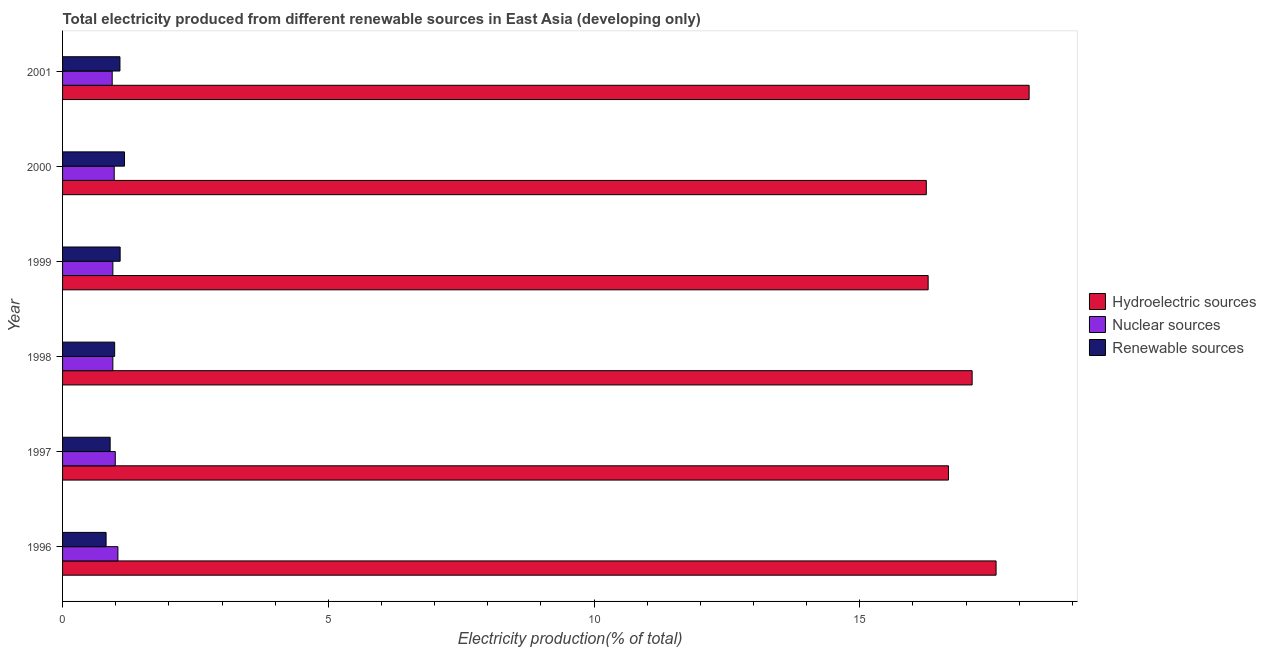How many different coloured bars are there?
Your response must be concise. 3. Are the number of bars per tick equal to the number of legend labels?
Keep it short and to the point. Yes. Are the number of bars on each tick of the Y-axis equal?
Your response must be concise. Yes. How many bars are there on the 2nd tick from the bottom?
Keep it short and to the point. 3. In how many cases, is the number of bars for a given year not equal to the number of legend labels?
Provide a short and direct response. 0. What is the percentage of electricity produced by hydroelectric sources in 1998?
Offer a very short reply. 17.11. Across all years, what is the maximum percentage of electricity produced by renewable sources?
Provide a short and direct response. 1.17. Across all years, what is the minimum percentage of electricity produced by nuclear sources?
Make the answer very short. 0.93. In which year was the percentage of electricity produced by renewable sources minimum?
Your answer should be very brief. 1996. What is the total percentage of electricity produced by nuclear sources in the graph?
Offer a very short reply. 5.83. What is the difference between the percentage of electricity produced by hydroelectric sources in 1998 and that in 1999?
Your response must be concise. 0.83. What is the difference between the percentage of electricity produced by hydroelectric sources in 1996 and the percentage of electricity produced by nuclear sources in 1999?
Your response must be concise. 16.62. In the year 1998, what is the difference between the percentage of electricity produced by nuclear sources and percentage of electricity produced by renewable sources?
Your response must be concise. -0.03. In how many years, is the percentage of electricity produced by nuclear sources greater than 11 %?
Provide a succinct answer. 0. What is the ratio of the percentage of electricity produced by hydroelectric sources in 1999 to that in 2000?
Your answer should be compact. 1. Is the percentage of electricity produced by hydroelectric sources in 1998 less than that in 1999?
Give a very brief answer. No. Is the difference between the percentage of electricity produced by nuclear sources in 1999 and 2001 greater than the difference between the percentage of electricity produced by renewable sources in 1999 and 2001?
Provide a short and direct response. Yes. What is the difference between the highest and the second highest percentage of electricity produced by nuclear sources?
Give a very brief answer. 0.05. What is the difference between the highest and the lowest percentage of electricity produced by hydroelectric sources?
Make the answer very short. 1.93. Is the sum of the percentage of electricity produced by renewable sources in 1996 and 1999 greater than the maximum percentage of electricity produced by nuclear sources across all years?
Offer a very short reply. Yes. What does the 2nd bar from the top in 1997 represents?
Provide a short and direct response. Nuclear sources. What does the 2nd bar from the bottom in 1999 represents?
Your answer should be very brief. Nuclear sources. Is it the case that in every year, the sum of the percentage of electricity produced by hydroelectric sources and percentage of electricity produced by nuclear sources is greater than the percentage of electricity produced by renewable sources?
Ensure brevity in your answer.  Yes. How many bars are there?
Make the answer very short. 18. Are all the bars in the graph horizontal?
Offer a very short reply. Yes. Are the values on the major ticks of X-axis written in scientific E-notation?
Your response must be concise. No. Does the graph contain any zero values?
Provide a short and direct response. No. Does the graph contain grids?
Offer a terse response. No. Where does the legend appear in the graph?
Your response must be concise. Center right. What is the title of the graph?
Provide a succinct answer. Total electricity produced from different renewable sources in East Asia (developing only). What is the Electricity production(% of total) of Hydroelectric sources in 1996?
Give a very brief answer. 17.56. What is the Electricity production(% of total) in Nuclear sources in 1996?
Provide a short and direct response. 1.04. What is the Electricity production(% of total) in Renewable sources in 1996?
Your answer should be compact. 0.82. What is the Electricity production(% of total) of Hydroelectric sources in 1997?
Your response must be concise. 16.67. What is the Electricity production(% of total) in Nuclear sources in 1997?
Offer a terse response. 0.99. What is the Electricity production(% of total) in Renewable sources in 1997?
Give a very brief answer. 0.9. What is the Electricity production(% of total) in Hydroelectric sources in 1998?
Make the answer very short. 17.11. What is the Electricity production(% of total) of Nuclear sources in 1998?
Provide a short and direct response. 0.95. What is the Electricity production(% of total) of Renewable sources in 1998?
Make the answer very short. 0.98. What is the Electricity production(% of total) in Hydroelectric sources in 1999?
Provide a short and direct response. 16.29. What is the Electricity production(% of total) of Nuclear sources in 1999?
Your response must be concise. 0.95. What is the Electricity production(% of total) of Renewable sources in 1999?
Your answer should be very brief. 1.08. What is the Electricity production(% of total) in Hydroelectric sources in 2000?
Provide a short and direct response. 16.25. What is the Electricity production(% of total) in Nuclear sources in 2000?
Provide a succinct answer. 0.97. What is the Electricity production(% of total) of Renewable sources in 2000?
Offer a very short reply. 1.17. What is the Electricity production(% of total) of Hydroelectric sources in 2001?
Provide a short and direct response. 18.19. What is the Electricity production(% of total) in Nuclear sources in 2001?
Give a very brief answer. 0.93. What is the Electricity production(% of total) in Renewable sources in 2001?
Make the answer very short. 1.08. Across all years, what is the maximum Electricity production(% of total) in Hydroelectric sources?
Make the answer very short. 18.19. Across all years, what is the maximum Electricity production(% of total) in Nuclear sources?
Keep it short and to the point. 1.04. Across all years, what is the maximum Electricity production(% of total) of Renewable sources?
Provide a succinct answer. 1.17. Across all years, what is the minimum Electricity production(% of total) of Hydroelectric sources?
Your answer should be compact. 16.25. Across all years, what is the minimum Electricity production(% of total) of Nuclear sources?
Provide a succinct answer. 0.93. Across all years, what is the minimum Electricity production(% of total) in Renewable sources?
Provide a short and direct response. 0.82. What is the total Electricity production(% of total) of Hydroelectric sources in the graph?
Your answer should be very brief. 102.07. What is the total Electricity production(% of total) of Nuclear sources in the graph?
Your answer should be compact. 5.83. What is the total Electricity production(% of total) of Renewable sources in the graph?
Keep it short and to the point. 6.02. What is the difference between the Electricity production(% of total) of Hydroelectric sources in 1996 and that in 1997?
Offer a terse response. 0.9. What is the difference between the Electricity production(% of total) in Nuclear sources in 1996 and that in 1997?
Keep it short and to the point. 0.05. What is the difference between the Electricity production(% of total) of Renewable sources in 1996 and that in 1997?
Offer a very short reply. -0.08. What is the difference between the Electricity production(% of total) in Hydroelectric sources in 1996 and that in 1998?
Your answer should be very brief. 0.45. What is the difference between the Electricity production(% of total) of Nuclear sources in 1996 and that in 1998?
Offer a terse response. 0.1. What is the difference between the Electricity production(% of total) of Renewable sources in 1996 and that in 1998?
Ensure brevity in your answer.  -0.16. What is the difference between the Electricity production(% of total) in Hydroelectric sources in 1996 and that in 1999?
Give a very brief answer. 1.28. What is the difference between the Electricity production(% of total) of Nuclear sources in 1996 and that in 1999?
Offer a very short reply. 0.09. What is the difference between the Electricity production(% of total) of Renewable sources in 1996 and that in 1999?
Offer a terse response. -0.26. What is the difference between the Electricity production(% of total) in Hydroelectric sources in 1996 and that in 2000?
Provide a succinct answer. 1.31. What is the difference between the Electricity production(% of total) in Nuclear sources in 1996 and that in 2000?
Keep it short and to the point. 0.07. What is the difference between the Electricity production(% of total) of Renewable sources in 1996 and that in 2000?
Make the answer very short. -0.35. What is the difference between the Electricity production(% of total) in Hydroelectric sources in 1996 and that in 2001?
Your answer should be very brief. -0.62. What is the difference between the Electricity production(% of total) of Nuclear sources in 1996 and that in 2001?
Offer a very short reply. 0.11. What is the difference between the Electricity production(% of total) of Renewable sources in 1996 and that in 2001?
Ensure brevity in your answer.  -0.26. What is the difference between the Electricity production(% of total) of Hydroelectric sources in 1997 and that in 1998?
Your answer should be compact. -0.45. What is the difference between the Electricity production(% of total) of Nuclear sources in 1997 and that in 1998?
Make the answer very short. 0.05. What is the difference between the Electricity production(% of total) of Renewable sources in 1997 and that in 1998?
Offer a very short reply. -0.08. What is the difference between the Electricity production(% of total) in Hydroelectric sources in 1997 and that in 1999?
Your response must be concise. 0.38. What is the difference between the Electricity production(% of total) in Nuclear sources in 1997 and that in 1999?
Offer a very short reply. 0.05. What is the difference between the Electricity production(% of total) of Renewable sources in 1997 and that in 1999?
Your answer should be compact. -0.19. What is the difference between the Electricity production(% of total) of Hydroelectric sources in 1997 and that in 2000?
Provide a succinct answer. 0.42. What is the difference between the Electricity production(% of total) in Renewable sources in 1997 and that in 2000?
Provide a short and direct response. -0.27. What is the difference between the Electricity production(% of total) in Hydroelectric sources in 1997 and that in 2001?
Your answer should be very brief. -1.52. What is the difference between the Electricity production(% of total) of Nuclear sources in 1997 and that in 2001?
Your response must be concise. 0.06. What is the difference between the Electricity production(% of total) in Renewable sources in 1997 and that in 2001?
Provide a short and direct response. -0.18. What is the difference between the Electricity production(% of total) of Hydroelectric sources in 1998 and that in 1999?
Offer a very short reply. 0.83. What is the difference between the Electricity production(% of total) of Nuclear sources in 1998 and that in 1999?
Make the answer very short. -0. What is the difference between the Electricity production(% of total) of Renewable sources in 1998 and that in 1999?
Your response must be concise. -0.1. What is the difference between the Electricity production(% of total) in Hydroelectric sources in 1998 and that in 2000?
Offer a very short reply. 0.86. What is the difference between the Electricity production(% of total) of Nuclear sources in 1998 and that in 2000?
Keep it short and to the point. -0.03. What is the difference between the Electricity production(% of total) of Renewable sources in 1998 and that in 2000?
Offer a very short reply. -0.19. What is the difference between the Electricity production(% of total) in Hydroelectric sources in 1998 and that in 2001?
Offer a terse response. -1.07. What is the difference between the Electricity production(% of total) of Nuclear sources in 1998 and that in 2001?
Offer a very short reply. 0.01. What is the difference between the Electricity production(% of total) in Renewable sources in 1998 and that in 2001?
Your answer should be compact. -0.1. What is the difference between the Electricity production(% of total) of Hydroelectric sources in 1999 and that in 2000?
Your response must be concise. 0.03. What is the difference between the Electricity production(% of total) in Nuclear sources in 1999 and that in 2000?
Your response must be concise. -0.03. What is the difference between the Electricity production(% of total) in Renewable sources in 1999 and that in 2000?
Your answer should be very brief. -0.08. What is the difference between the Electricity production(% of total) in Hydroelectric sources in 1999 and that in 2001?
Ensure brevity in your answer.  -1.9. What is the difference between the Electricity production(% of total) in Nuclear sources in 1999 and that in 2001?
Make the answer very short. 0.01. What is the difference between the Electricity production(% of total) of Renewable sources in 1999 and that in 2001?
Offer a very short reply. 0. What is the difference between the Electricity production(% of total) in Hydroelectric sources in 2000 and that in 2001?
Offer a very short reply. -1.93. What is the difference between the Electricity production(% of total) in Nuclear sources in 2000 and that in 2001?
Offer a terse response. 0.04. What is the difference between the Electricity production(% of total) of Renewable sources in 2000 and that in 2001?
Provide a short and direct response. 0.09. What is the difference between the Electricity production(% of total) in Hydroelectric sources in 1996 and the Electricity production(% of total) in Nuclear sources in 1997?
Offer a terse response. 16.57. What is the difference between the Electricity production(% of total) in Hydroelectric sources in 1996 and the Electricity production(% of total) in Renewable sources in 1997?
Keep it short and to the point. 16.67. What is the difference between the Electricity production(% of total) in Nuclear sources in 1996 and the Electricity production(% of total) in Renewable sources in 1997?
Offer a very short reply. 0.15. What is the difference between the Electricity production(% of total) in Hydroelectric sources in 1996 and the Electricity production(% of total) in Nuclear sources in 1998?
Ensure brevity in your answer.  16.62. What is the difference between the Electricity production(% of total) of Hydroelectric sources in 1996 and the Electricity production(% of total) of Renewable sources in 1998?
Provide a succinct answer. 16.58. What is the difference between the Electricity production(% of total) of Nuclear sources in 1996 and the Electricity production(% of total) of Renewable sources in 1998?
Your response must be concise. 0.06. What is the difference between the Electricity production(% of total) of Hydroelectric sources in 1996 and the Electricity production(% of total) of Nuclear sources in 1999?
Your answer should be very brief. 16.62. What is the difference between the Electricity production(% of total) of Hydroelectric sources in 1996 and the Electricity production(% of total) of Renewable sources in 1999?
Offer a terse response. 16.48. What is the difference between the Electricity production(% of total) of Nuclear sources in 1996 and the Electricity production(% of total) of Renewable sources in 1999?
Provide a short and direct response. -0.04. What is the difference between the Electricity production(% of total) of Hydroelectric sources in 1996 and the Electricity production(% of total) of Nuclear sources in 2000?
Your answer should be compact. 16.59. What is the difference between the Electricity production(% of total) in Hydroelectric sources in 1996 and the Electricity production(% of total) in Renewable sources in 2000?
Give a very brief answer. 16.4. What is the difference between the Electricity production(% of total) in Nuclear sources in 1996 and the Electricity production(% of total) in Renewable sources in 2000?
Keep it short and to the point. -0.12. What is the difference between the Electricity production(% of total) of Hydroelectric sources in 1996 and the Electricity production(% of total) of Nuclear sources in 2001?
Offer a very short reply. 16.63. What is the difference between the Electricity production(% of total) in Hydroelectric sources in 1996 and the Electricity production(% of total) in Renewable sources in 2001?
Your answer should be very brief. 16.49. What is the difference between the Electricity production(% of total) of Nuclear sources in 1996 and the Electricity production(% of total) of Renewable sources in 2001?
Keep it short and to the point. -0.04. What is the difference between the Electricity production(% of total) of Hydroelectric sources in 1997 and the Electricity production(% of total) of Nuclear sources in 1998?
Offer a very short reply. 15.72. What is the difference between the Electricity production(% of total) in Hydroelectric sources in 1997 and the Electricity production(% of total) in Renewable sources in 1998?
Offer a very short reply. 15.69. What is the difference between the Electricity production(% of total) of Nuclear sources in 1997 and the Electricity production(% of total) of Renewable sources in 1998?
Your answer should be compact. 0.01. What is the difference between the Electricity production(% of total) of Hydroelectric sources in 1997 and the Electricity production(% of total) of Nuclear sources in 1999?
Offer a very short reply. 15.72. What is the difference between the Electricity production(% of total) of Hydroelectric sources in 1997 and the Electricity production(% of total) of Renewable sources in 1999?
Offer a very short reply. 15.59. What is the difference between the Electricity production(% of total) of Nuclear sources in 1997 and the Electricity production(% of total) of Renewable sources in 1999?
Provide a succinct answer. -0.09. What is the difference between the Electricity production(% of total) of Hydroelectric sources in 1997 and the Electricity production(% of total) of Nuclear sources in 2000?
Provide a short and direct response. 15.7. What is the difference between the Electricity production(% of total) in Hydroelectric sources in 1997 and the Electricity production(% of total) in Renewable sources in 2000?
Ensure brevity in your answer.  15.5. What is the difference between the Electricity production(% of total) in Nuclear sources in 1997 and the Electricity production(% of total) in Renewable sources in 2000?
Provide a succinct answer. -0.17. What is the difference between the Electricity production(% of total) in Hydroelectric sources in 1997 and the Electricity production(% of total) in Nuclear sources in 2001?
Your response must be concise. 15.73. What is the difference between the Electricity production(% of total) in Hydroelectric sources in 1997 and the Electricity production(% of total) in Renewable sources in 2001?
Offer a terse response. 15.59. What is the difference between the Electricity production(% of total) of Nuclear sources in 1997 and the Electricity production(% of total) of Renewable sources in 2001?
Make the answer very short. -0.09. What is the difference between the Electricity production(% of total) in Hydroelectric sources in 1998 and the Electricity production(% of total) in Nuclear sources in 1999?
Offer a very short reply. 16.17. What is the difference between the Electricity production(% of total) of Hydroelectric sources in 1998 and the Electricity production(% of total) of Renewable sources in 1999?
Your response must be concise. 16.03. What is the difference between the Electricity production(% of total) of Nuclear sources in 1998 and the Electricity production(% of total) of Renewable sources in 1999?
Offer a very short reply. -0.14. What is the difference between the Electricity production(% of total) in Hydroelectric sources in 1998 and the Electricity production(% of total) in Nuclear sources in 2000?
Make the answer very short. 16.14. What is the difference between the Electricity production(% of total) in Hydroelectric sources in 1998 and the Electricity production(% of total) in Renewable sources in 2000?
Keep it short and to the point. 15.95. What is the difference between the Electricity production(% of total) in Nuclear sources in 1998 and the Electricity production(% of total) in Renewable sources in 2000?
Give a very brief answer. -0.22. What is the difference between the Electricity production(% of total) in Hydroelectric sources in 1998 and the Electricity production(% of total) in Nuclear sources in 2001?
Keep it short and to the point. 16.18. What is the difference between the Electricity production(% of total) of Hydroelectric sources in 1998 and the Electricity production(% of total) of Renewable sources in 2001?
Ensure brevity in your answer.  16.03. What is the difference between the Electricity production(% of total) of Nuclear sources in 1998 and the Electricity production(% of total) of Renewable sources in 2001?
Make the answer very short. -0.13. What is the difference between the Electricity production(% of total) in Hydroelectric sources in 1999 and the Electricity production(% of total) in Nuclear sources in 2000?
Offer a terse response. 15.31. What is the difference between the Electricity production(% of total) of Hydroelectric sources in 1999 and the Electricity production(% of total) of Renewable sources in 2000?
Ensure brevity in your answer.  15.12. What is the difference between the Electricity production(% of total) in Nuclear sources in 1999 and the Electricity production(% of total) in Renewable sources in 2000?
Provide a short and direct response. -0.22. What is the difference between the Electricity production(% of total) of Hydroelectric sources in 1999 and the Electricity production(% of total) of Nuclear sources in 2001?
Give a very brief answer. 15.35. What is the difference between the Electricity production(% of total) in Hydroelectric sources in 1999 and the Electricity production(% of total) in Renewable sources in 2001?
Your answer should be compact. 15.21. What is the difference between the Electricity production(% of total) in Nuclear sources in 1999 and the Electricity production(% of total) in Renewable sources in 2001?
Your response must be concise. -0.13. What is the difference between the Electricity production(% of total) in Hydroelectric sources in 2000 and the Electricity production(% of total) in Nuclear sources in 2001?
Give a very brief answer. 15.32. What is the difference between the Electricity production(% of total) of Hydroelectric sources in 2000 and the Electricity production(% of total) of Renewable sources in 2001?
Your answer should be compact. 15.17. What is the difference between the Electricity production(% of total) of Nuclear sources in 2000 and the Electricity production(% of total) of Renewable sources in 2001?
Ensure brevity in your answer.  -0.11. What is the average Electricity production(% of total) of Hydroelectric sources per year?
Make the answer very short. 17.01. What is the average Electricity production(% of total) in Nuclear sources per year?
Keep it short and to the point. 0.97. In the year 1996, what is the difference between the Electricity production(% of total) of Hydroelectric sources and Electricity production(% of total) of Nuclear sources?
Keep it short and to the point. 16.52. In the year 1996, what is the difference between the Electricity production(% of total) in Hydroelectric sources and Electricity production(% of total) in Renewable sources?
Your answer should be compact. 16.75. In the year 1996, what is the difference between the Electricity production(% of total) in Nuclear sources and Electricity production(% of total) in Renewable sources?
Give a very brief answer. 0.22. In the year 1997, what is the difference between the Electricity production(% of total) in Hydroelectric sources and Electricity production(% of total) in Nuclear sources?
Provide a short and direct response. 15.68. In the year 1997, what is the difference between the Electricity production(% of total) of Hydroelectric sources and Electricity production(% of total) of Renewable sources?
Keep it short and to the point. 15.77. In the year 1997, what is the difference between the Electricity production(% of total) in Nuclear sources and Electricity production(% of total) in Renewable sources?
Provide a short and direct response. 0.1. In the year 1998, what is the difference between the Electricity production(% of total) of Hydroelectric sources and Electricity production(% of total) of Nuclear sources?
Make the answer very short. 16.17. In the year 1998, what is the difference between the Electricity production(% of total) of Hydroelectric sources and Electricity production(% of total) of Renewable sources?
Give a very brief answer. 16.13. In the year 1998, what is the difference between the Electricity production(% of total) in Nuclear sources and Electricity production(% of total) in Renewable sources?
Your answer should be compact. -0.03. In the year 1999, what is the difference between the Electricity production(% of total) in Hydroelectric sources and Electricity production(% of total) in Nuclear sources?
Provide a succinct answer. 15.34. In the year 1999, what is the difference between the Electricity production(% of total) of Hydroelectric sources and Electricity production(% of total) of Renewable sources?
Provide a succinct answer. 15.2. In the year 1999, what is the difference between the Electricity production(% of total) in Nuclear sources and Electricity production(% of total) in Renewable sources?
Your response must be concise. -0.14. In the year 2000, what is the difference between the Electricity production(% of total) in Hydroelectric sources and Electricity production(% of total) in Nuclear sources?
Make the answer very short. 15.28. In the year 2000, what is the difference between the Electricity production(% of total) of Hydroelectric sources and Electricity production(% of total) of Renewable sources?
Provide a short and direct response. 15.09. In the year 2000, what is the difference between the Electricity production(% of total) of Nuclear sources and Electricity production(% of total) of Renewable sources?
Keep it short and to the point. -0.19. In the year 2001, what is the difference between the Electricity production(% of total) of Hydroelectric sources and Electricity production(% of total) of Nuclear sources?
Ensure brevity in your answer.  17.25. In the year 2001, what is the difference between the Electricity production(% of total) of Hydroelectric sources and Electricity production(% of total) of Renewable sources?
Provide a short and direct response. 17.11. In the year 2001, what is the difference between the Electricity production(% of total) of Nuclear sources and Electricity production(% of total) of Renewable sources?
Make the answer very short. -0.15. What is the ratio of the Electricity production(% of total) in Hydroelectric sources in 1996 to that in 1997?
Offer a very short reply. 1.05. What is the ratio of the Electricity production(% of total) of Nuclear sources in 1996 to that in 1997?
Offer a very short reply. 1.05. What is the ratio of the Electricity production(% of total) in Renewable sources in 1996 to that in 1997?
Give a very brief answer. 0.91. What is the ratio of the Electricity production(% of total) in Hydroelectric sources in 1996 to that in 1998?
Ensure brevity in your answer.  1.03. What is the ratio of the Electricity production(% of total) of Nuclear sources in 1996 to that in 1998?
Offer a terse response. 1.1. What is the ratio of the Electricity production(% of total) in Renewable sources in 1996 to that in 1998?
Give a very brief answer. 0.84. What is the ratio of the Electricity production(% of total) in Hydroelectric sources in 1996 to that in 1999?
Offer a very short reply. 1.08. What is the ratio of the Electricity production(% of total) in Nuclear sources in 1996 to that in 1999?
Give a very brief answer. 1.1. What is the ratio of the Electricity production(% of total) in Renewable sources in 1996 to that in 1999?
Your answer should be compact. 0.76. What is the ratio of the Electricity production(% of total) of Hydroelectric sources in 1996 to that in 2000?
Give a very brief answer. 1.08. What is the ratio of the Electricity production(% of total) in Nuclear sources in 1996 to that in 2000?
Offer a very short reply. 1.07. What is the ratio of the Electricity production(% of total) of Renewable sources in 1996 to that in 2000?
Keep it short and to the point. 0.7. What is the ratio of the Electricity production(% of total) of Hydroelectric sources in 1996 to that in 2001?
Ensure brevity in your answer.  0.97. What is the ratio of the Electricity production(% of total) of Nuclear sources in 1996 to that in 2001?
Offer a very short reply. 1.11. What is the ratio of the Electricity production(% of total) of Renewable sources in 1996 to that in 2001?
Your response must be concise. 0.76. What is the ratio of the Electricity production(% of total) of Nuclear sources in 1997 to that in 1998?
Give a very brief answer. 1.05. What is the ratio of the Electricity production(% of total) in Renewable sources in 1997 to that in 1998?
Your response must be concise. 0.91. What is the ratio of the Electricity production(% of total) of Hydroelectric sources in 1997 to that in 1999?
Offer a very short reply. 1.02. What is the ratio of the Electricity production(% of total) of Nuclear sources in 1997 to that in 1999?
Make the answer very short. 1.05. What is the ratio of the Electricity production(% of total) in Renewable sources in 1997 to that in 1999?
Offer a very short reply. 0.83. What is the ratio of the Electricity production(% of total) in Hydroelectric sources in 1997 to that in 2000?
Give a very brief answer. 1.03. What is the ratio of the Electricity production(% of total) of Nuclear sources in 1997 to that in 2000?
Your answer should be very brief. 1.02. What is the ratio of the Electricity production(% of total) of Renewable sources in 1997 to that in 2000?
Provide a short and direct response. 0.77. What is the ratio of the Electricity production(% of total) in Hydroelectric sources in 1997 to that in 2001?
Provide a short and direct response. 0.92. What is the ratio of the Electricity production(% of total) of Nuclear sources in 1997 to that in 2001?
Your answer should be compact. 1.06. What is the ratio of the Electricity production(% of total) of Renewable sources in 1997 to that in 2001?
Make the answer very short. 0.83. What is the ratio of the Electricity production(% of total) in Hydroelectric sources in 1998 to that in 1999?
Ensure brevity in your answer.  1.05. What is the ratio of the Electricity production(% of total) in Renewable sources in 1998 to that in 1999?
Keep it short and to the point. 0.9. What is the ratio of the Electricity production(% of total) in Hydroelectric sources in 1998 to that in 2000?
Keep it short and to the point. 1.05. What is the ratio of the Electricity production(% of total) of Nuclear sources in 1998 to that in 2000?
Ensure brevity in your answer.  0.97. What is the ratio of the Electricity production(% of total) of Renewable sources in 1998 to that in 2000?
Your answer should be very brief. 0.84. What is the ratio of the Electricity production(% of total) in Hydroelectric sources in 1998 to that in 2001?
Your response must be concise. 0.94. What is the ratio of the Electricity production(% of total) of Nuclear sources in 1998 to that in 2001?
Ensure brevity in your answer.  1.01. What is the ratio of the Electricity production(% of total) of Renewable sources in 1998 to that in 2001?
Your answer should be very brief. 0.91. What is the ratio of the Electricity production(% of total) in Nuclear sources in 1999 to that in 2000?
Your answer should be very brief. 0.97. What is the ratio of the Electricity production(% of total) in Renewable sources in 1999 to that in 2000?
Ensure brevity in your answer.  0.93. What is the ratio of the Electricity production(% of total) of Hydroelectric sources in 1999 to that in 2001?
Provide a short and direct response. 0.9. What is the ratio of the Electricity production(% of total) of Nuclear sources in 1999 to that in 2001?
Ensure brevity in your answer.  1.01. What is the ratio of the Electricity production(% of total) of Renewable sources in 1999 to that in 2001?
Offer a terse response. 1. What is the ratio of the Electricity production(% of total) of Hydroelectric sources in 2000 to that in 2001?
Keep it short and to the point. 0.89. What is the ratio of the Electricity production(% of total) of Nuclear sources in 2000 to that in 2001?
Provide a short and direct response. 1.04. What is the ratio of the Electricity production(% of total) of Renewable sources in 2000 to that in 2001?
Offer a very short reply. 1.08. What is the difference between the highest and the second highest Electricity production(% of total) in Hydroelectric sources?
Provide a short and direct response. 0.62. What is the difference between the highest and the second highest Electricity production(% of total) of Nuclear sources?
Your answer should be very brief. 0.05. What is the difference between the highest and the second highest Electricity production(% of total) in Renewable sources?
Provide a short and direct response. 0.08. What is the difference between the highest and the lowest Electricity production(% of total) in Hydroelectric sources?
Keep it short and to the point. 1.93. What is the difference between the highest and the lowest Electricity production(% of total) of Nuclear sources?
Keep it short and to the point. 0.11. What is the difference between the highest and the lowest Electricity production(% of total) in Renewable sources?
Your answer should be compact. 0.35. 